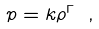Convert formula to latex. <formula><loc_0><loc_0><loc_500><loc_500>p = k \rho ^ { \Gamma } \ ,</formula> 